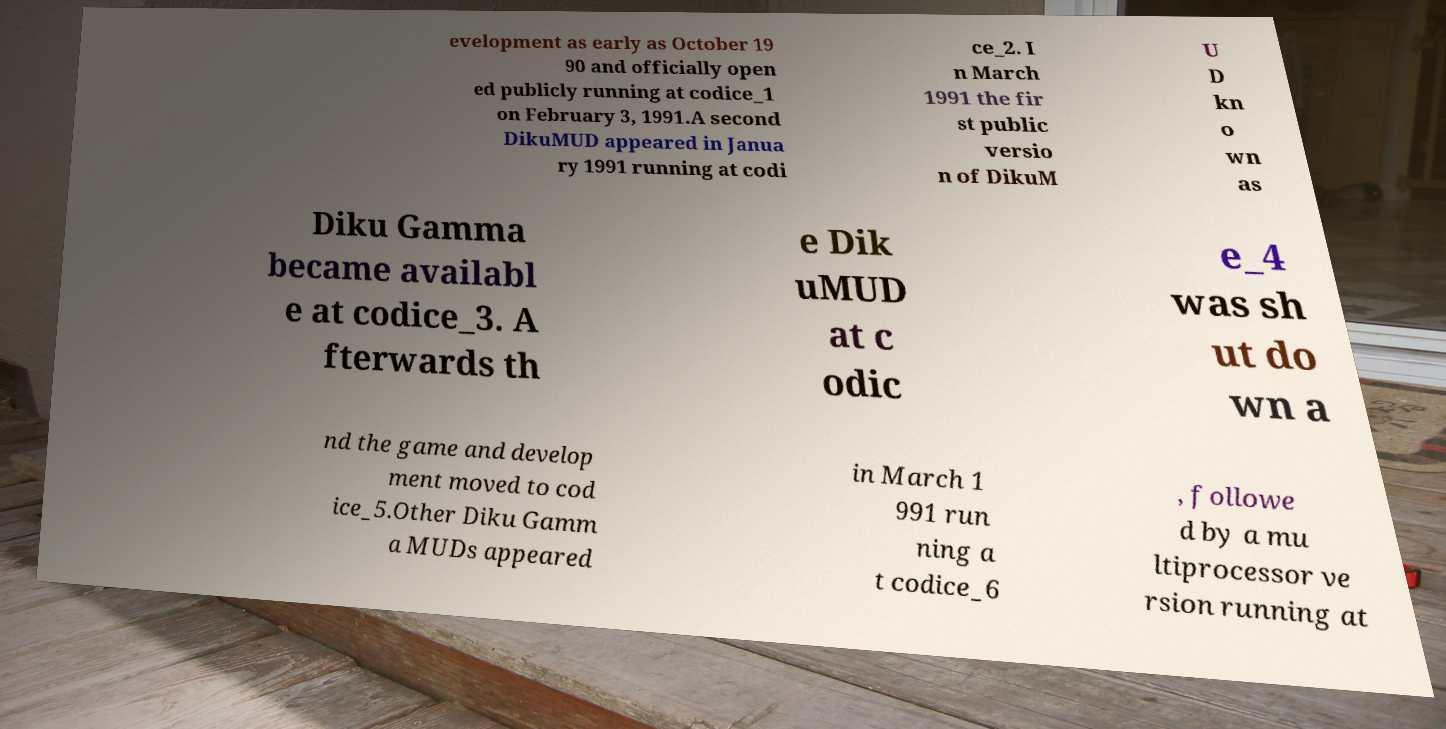Please identify and transcribe the text found in this image. evelopment as early as October 19 90 and officially open ed publicly running at codice_1 on February 3, 1991.A second DikuMUD appeared in Janua ry 1991 running at codi ce_2. I n March 1991 the fir st public versio n of DikuM U D kn o wn as Diku Gamma became availabl e at codice_3. A fterwards th e Dik uMUD at c odic e_4 was sh ut do wn a nd the game and develop ment moved to cod ice_5.Other Diku Gamm a MUDs appeared in March 1 991 run ning a t codice_6 , followe d by a mu ltiprocessor ve rsion running at 